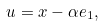<formula> <loc_0><loc_0><loc_500><loc_500>u = x - \alpha e _ { 1 } ,</formula> 